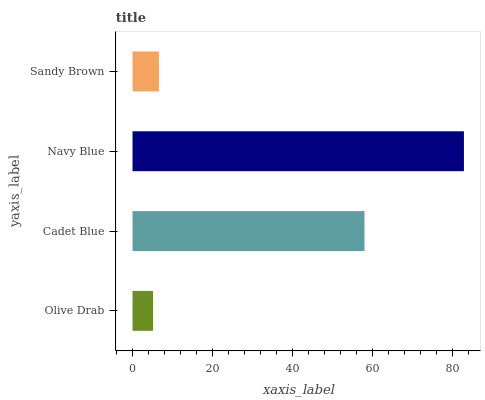Is Olive Drab the minimum?
Answer yes or no. Yes. Is Navy Blue the maximum?
Answer yes or no. Yes. Is Cadet Blue the minimum?
Answer yes or no. No. Is Cadet Blue the maximum?
Answer yes or no. No. Is Cadet Blue greater than Olive Drab?
Answer yes or no. Yes. Is Olive Drab less than Cadet Blue?
Answer yes or no. Yes. Is Olive Drab greater than Cadet Blue?
Answer yes or no. No. Is Cadet Blue less than Olive Drab?
Answer yes or no. No. Is Cadet Blue the high median?
Answer yes or no. Yes. Is Sandy Brown the low median?
Answer yes or no. Yes. Is Navy Blue the high median?
Answer yes or no. No. Is Cadet Blue the low median?
Answer yes or no. No. 